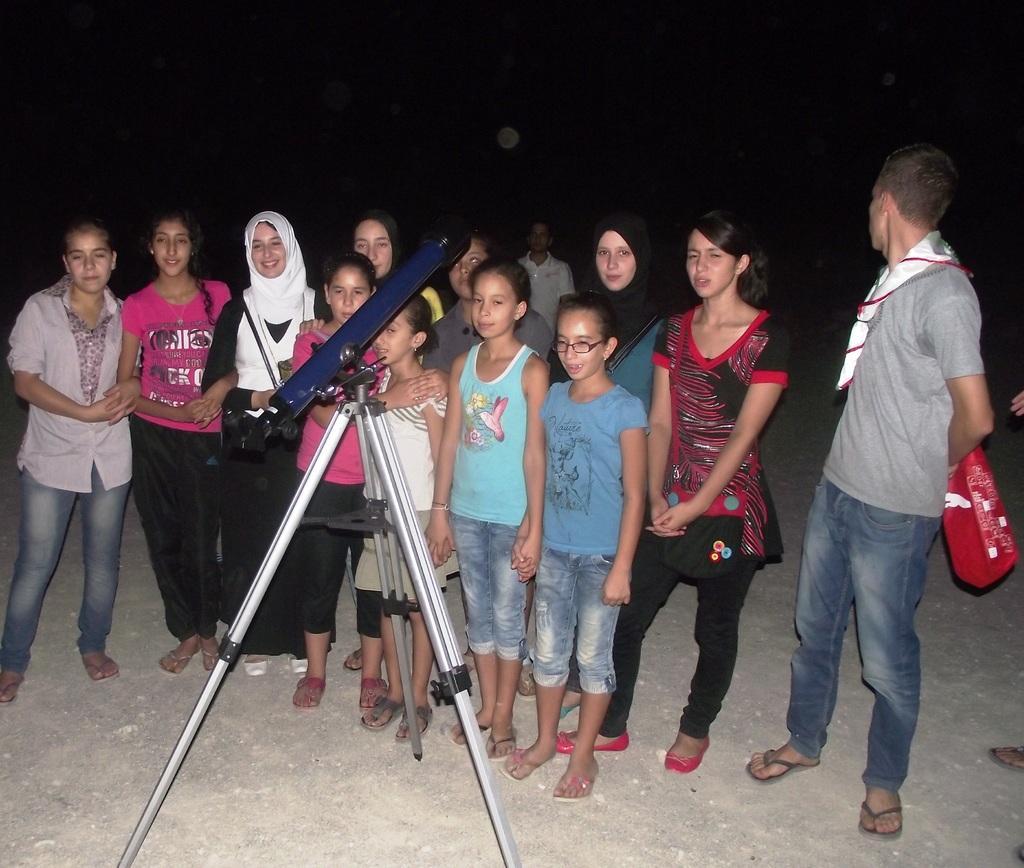Please provide a concise description of this image. In the center of the image we can see a group of people are standing. At the top of the image sky is there. At the bottom of the image ground is present. On the left side of the image we can see a stand and an object are present. 